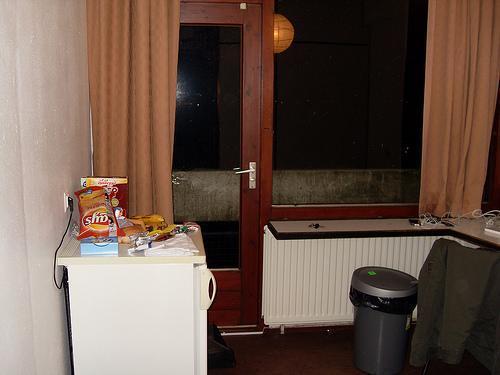How many bags of Lay's are on top of the fridge?
Give a very brief answer. 1. 